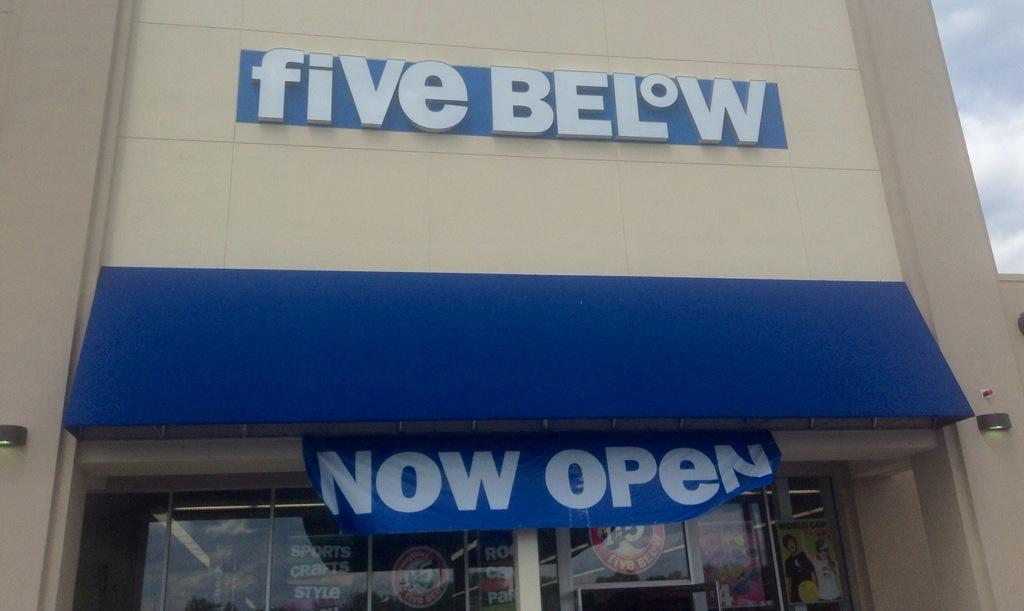What type of structure is present in the image? There is a building in the image. What can be seen written on the building? The building has the words "Five Below" written on it. What type of tin can be seen in the image? There is no tin present in the image. What pet can be seen playing with a ball in the image? There is no pet or ball present in the image. 